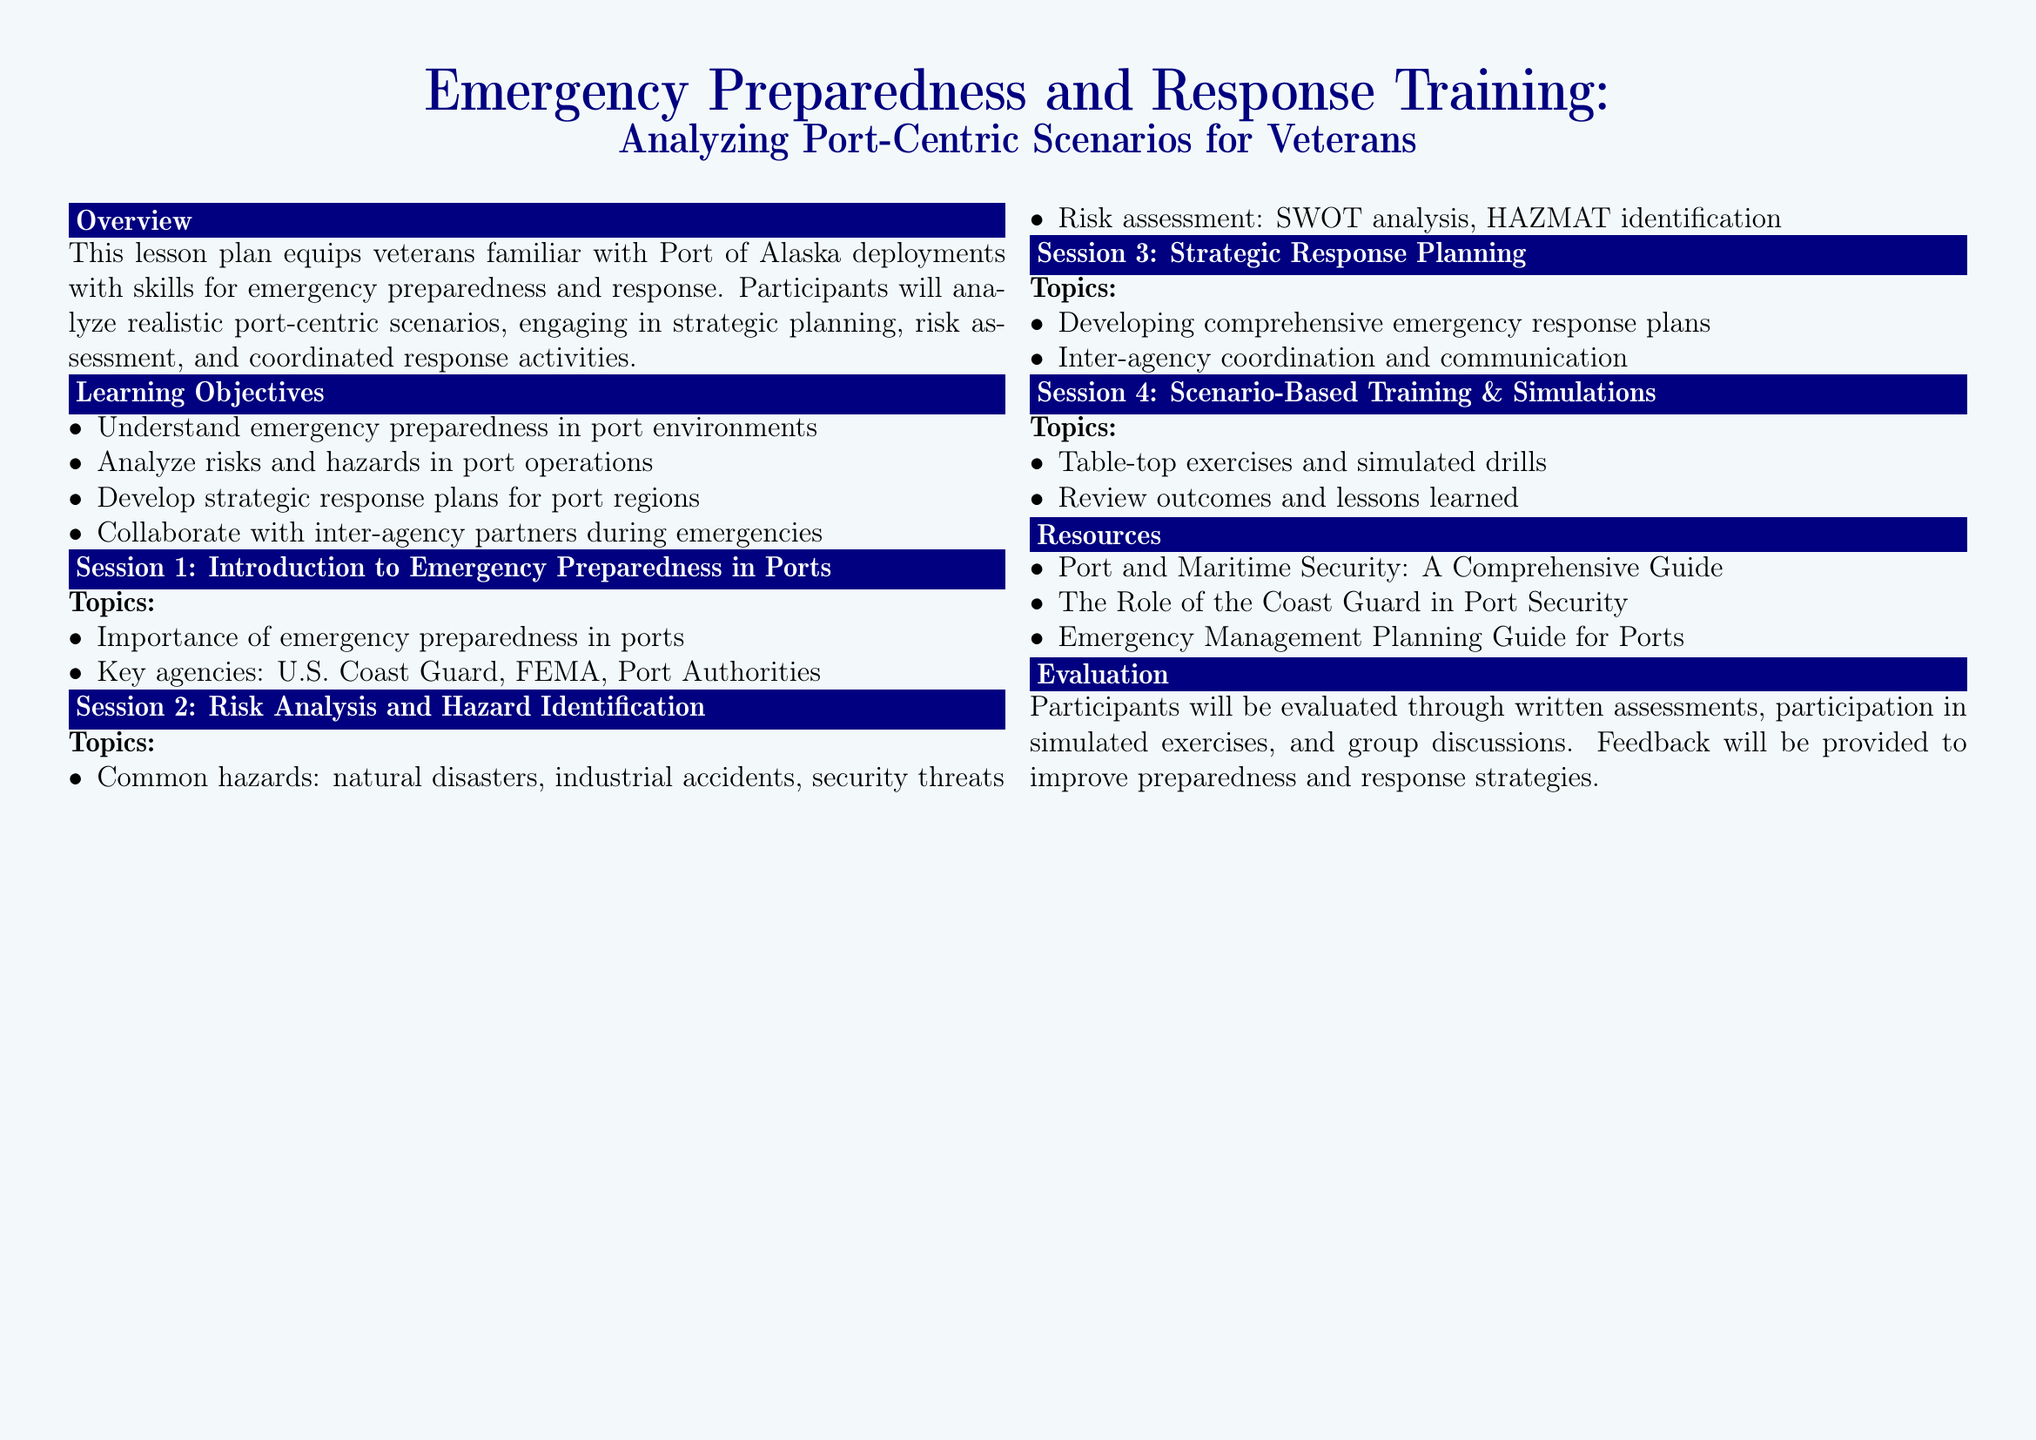What is the focus of the lesson plan? The lesson plan focuses on equipping veterans with skills for emergency preparedness and response in port environments.
Answer: emergency preparedness and response Who are the key agencies mentioned? The lesson plan lists the U.S. Coast Guard, FEMA, and Port Authorities as key agencies involved in emergency preparedness in ports.
Answer: U.S. Coast Guard, FEMA, Port Authorities What is a common hazard identified in the lesson? The lesson discusses various common hazards, one of which is natural disasters.
Answer: natural disasters How will participants be evaluated? Participants will be evaluated through written assessments, participation in simulated exercises, and group discussions.
Answer: written assessments, simulated exercises, group discussions What type of exercises will be conducted in Session 4? Session 4 includes table-top exercises and simulated drills as part of the scenario-based training.
Answer: table-top exercises, simulated drills What is the purpose of SWOT analysis in the lesson? SWOT analysis is used for risk assessment during the risk analysis and hazard identification session.
Answer: risk assessment What will participants learn about inter-agency efforts? Participants will learn about inter-agency coordination and communication during strategic response planning.
Answer: inter-agency coordination and communication How many sessions are outlined in the lesson plan? The lesson plan outlines four sessions focused on different aspects of emergency preparedness.
Answer: four sessions 